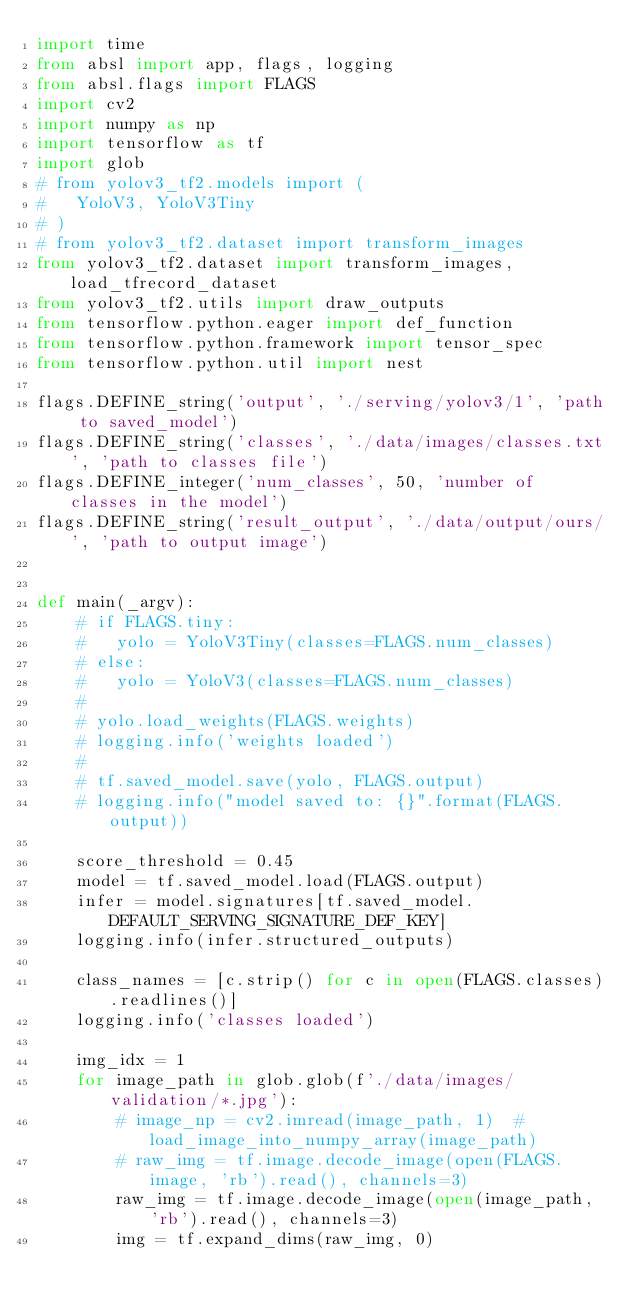<code> <loc_0><loc_0><loc_500><loc_500><_Python_>import time
from absl import app, flags, logging
from absl.flags import FLAGS
import cv2
import numpy as np
import tensorflow as tf
import glob
# from yolov3_tf2.models import (
# 	YoloV3, YoloV3Tiny
# )
# from yolov3_tf2.dataset import transform_images
from yolov3_tf2.dataset import transform_images, load_tfrecord_dataset
from yolov3_tf2.utils import draw_outputs
from tensorflow.python.eager import def_function
from tensorflow.python.framework import tensor_spec
from tensorflow.python.util import nest

flags.DEFINE_string('output', './serving/yolov3/1', 'path to saved_model')
flags.DEFINE_string('classes', './data/images/classes.txt', 'path to classes file')
flags.DEFINE_integer('num_classes', 50, 'number of classes in the model')
flags.DEFINE_string('result_output', './data/output/ours/', 'path to output image')


def main(_argv):
    # if FLAGS.tiny:
    # 	yolo = YoloV3Tiny(classes=FLAGS.num_classes)
    # else:
    # 	yolo = YoloV3(classes=FLAGS.num_classes)
    #
    # yolo.load_weights(FLAGS.weights)
    # logging.info('weights loaded')
    #
    # tf.saved_model.save(yolo, FLAGS.output)
    # logging.info("model saved to: {}".format(FLAGS.output))

    score_threshold = 0.45
    model = tf.saved_model.load(FLAGS.output)
    infer = model.signatures[tf.saved_model.DEFAULT_SERVING_SIGNATURE_DEF_KEY]
    logging.info(infer.structured_outputs)

    class_names = [c.strip() for c in open(FLAGS.classes).readlines()]
    logging.info('classes loaded')

    img_idx = 1
    for image_path in glob.glob(f'./data/images/validation/*.jpg'):
        # image_np = cv2.imread(image_path, 1)  # load_image_into_numpy_array(image_path)
        # raw_img = tf.image.decode_image(open(FLAGS.image, 'rb').read(), channels=3)
        raw_img = tf.image.decode_image(open(image_path, 'rb').read(), channels=3)
        img = tf.expand_dims(raw_img, 0)</code> 